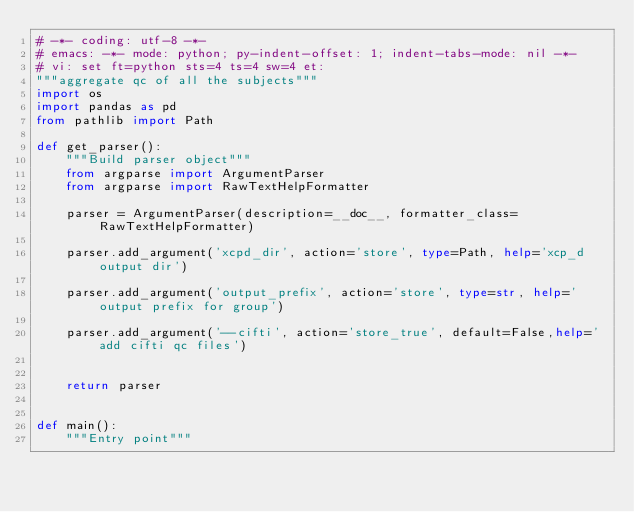Convert code to text. <code><loc_0><loc_0><loc_500><loc_500><_Python_># -*- coding: utf-8 -*-
# emacs: -*- mode: python; py-indent-offset: 1; indent-tabs-mode: nil -*-
# vi: set ft=python sts=4 ts=4 sw=4 et:
"""aggregate qc of all the subjects"""
import os
import pandas as pd
from pathlib import Path 

def get_parser():
    """Build parser object"""
    from argparse import ArgumentParser
    from argparse import RawTextHelpFormatter

    parser = ArgumentParser(description=__doc__, formatter_class=RawTextHelpFormatter)

    parser.add_argument('xcpd_dir', action='store', type=Path, help='xcp_d output dir')
    
    parser.add_argument('output_prefix', action='store', type=str, help='output prefix for group')

    parser.add_argument('--cifti', action='store_true', default=False,help=' add cifti qc files')


    return parser


def main():
    """Entry point"""
    </code> 